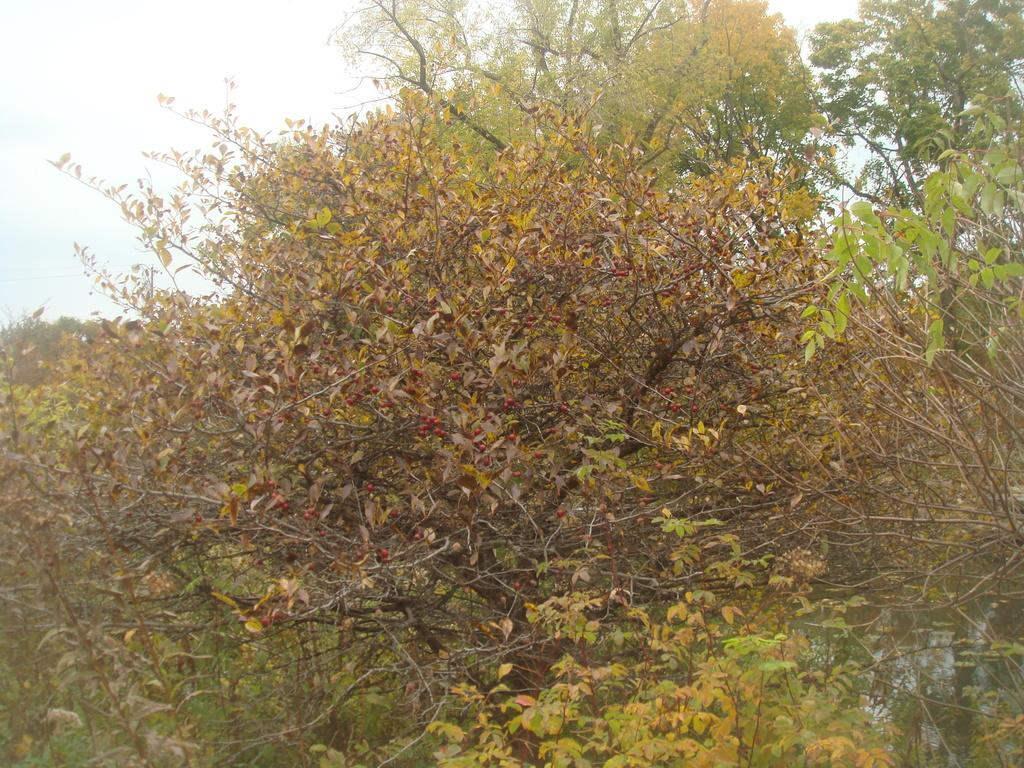What type of vegetation can be seen in the image? There are trees in the image. Can you describe the trees in the image? The provided facts do not give specific details about the trees, so we cannot describe them further. What type of lettuce is being used as fuel for the dog in the image? There is no dog or lettuce present in the image, and therefore no such activity can be observed. 